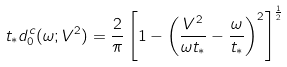Convert formula to latex. <formula><loc_0><loc_0><loc_500><loc_500>t _ { \ast } d _ { 0 } ^ { c } ( \omega ; V ^ { 2 } ) = \frac { 2 } { \pi } \left [ 1 - \left ( \frac { V ^ { 2 } } { \omega t _ { \ast } } - \frac { \omega } { t _ { \ast } } \right ) ^ { 2 } \right ] ^ { \frac { 1 } { 2 } }</formula> 